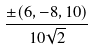<formula> <loc_0><loc_0><loc_500><loc_500>\frac { \pm ( 6 , - 8 , 1 0 ) } { 1 0 \sqrt { 2 } }</formula> 